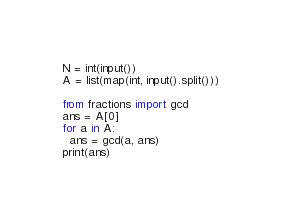Convert code to text. <code><loc_0><loc_0><loc_500><loc_500><_Python_>N = int(input())
A = list(map(int, input().split()))

from fractions import gcd
ans = A[0]
for a in A:
  ans = gcd(a, ans)
print(ans)</code> 